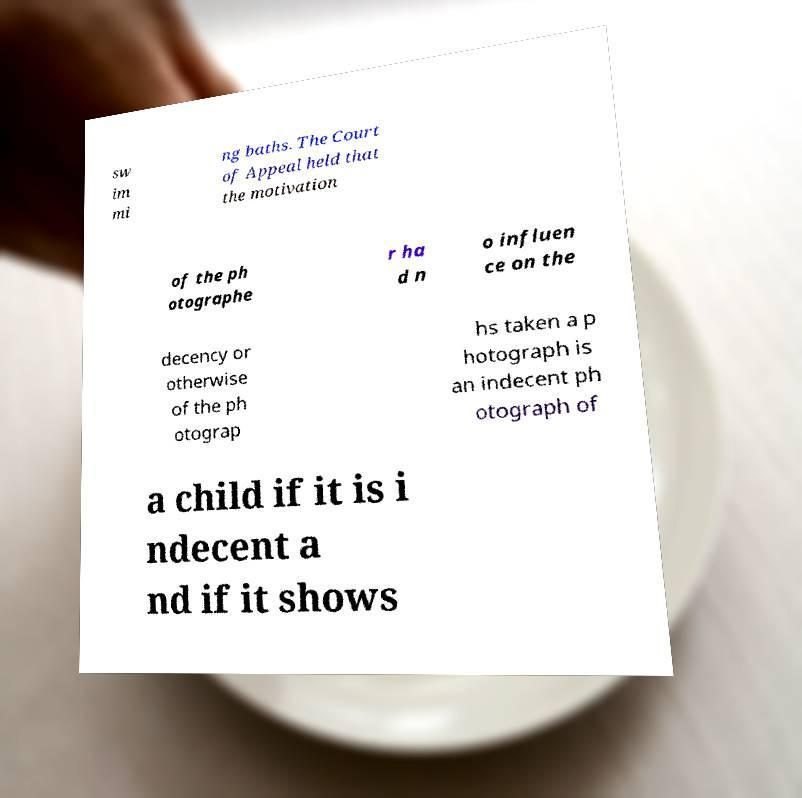Can you accurately transcribe the text from the provided image for me? sw im mi ng baths. The Court of Appeal held that the motivation of the ph otographe r ha d n o influen ce on the decency or otherwise of the ph otograp hs taken a p hotograph is an indecent ph otograph of a child if it is i ndecent a nd if it shows 